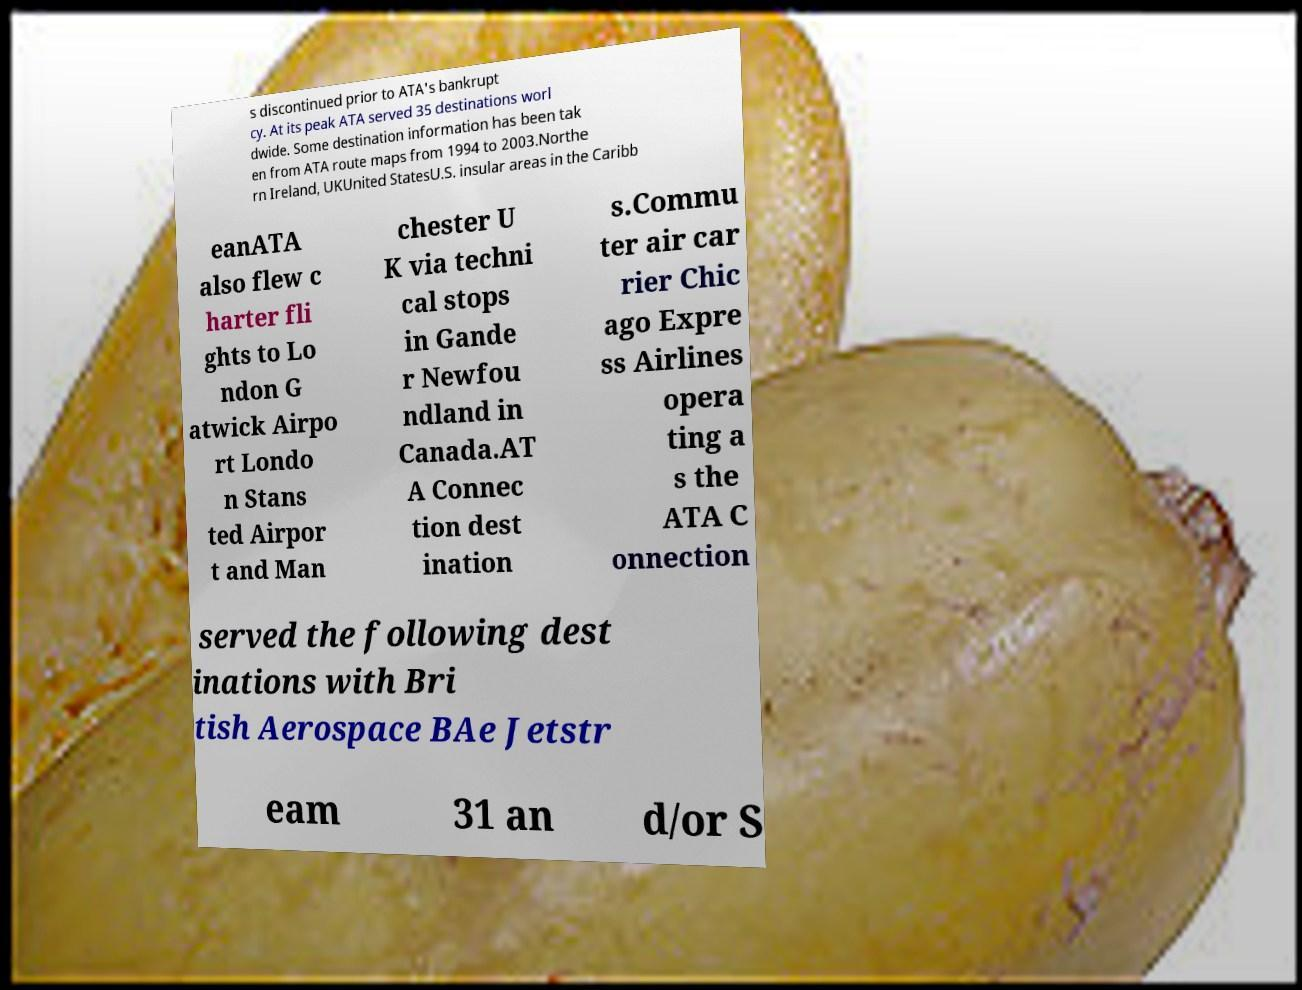For documentation purposes, I need the text within this image transcribed. Could you provide that? s discontinued prior to ATA's bankrupt cy. At its peak ATA served 35 destinations worl dwide. Some destination information has been tak en from ATA route maps from 1994 to 2003.Northe rn Ireland, UKUnited StatesU.S. insular areas in the Caribb eanATA also flew c harter fli ghts to Lo ndon G atwick Airpo rt Londo n Stans ted Airpor t and Man chester U K via techni cal stops in Gande r Newfou ndland in Canada.AT A Connec tion dest ination s.Commu ter air car rier Chic ago Expre ss Airlines opera ting a s the ATA C onnection served the following dest inations with Bri tish Aerospace BAe Jetstr eam 31 an d/or S 